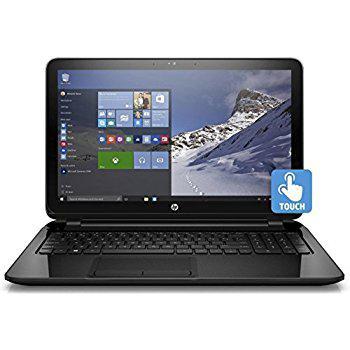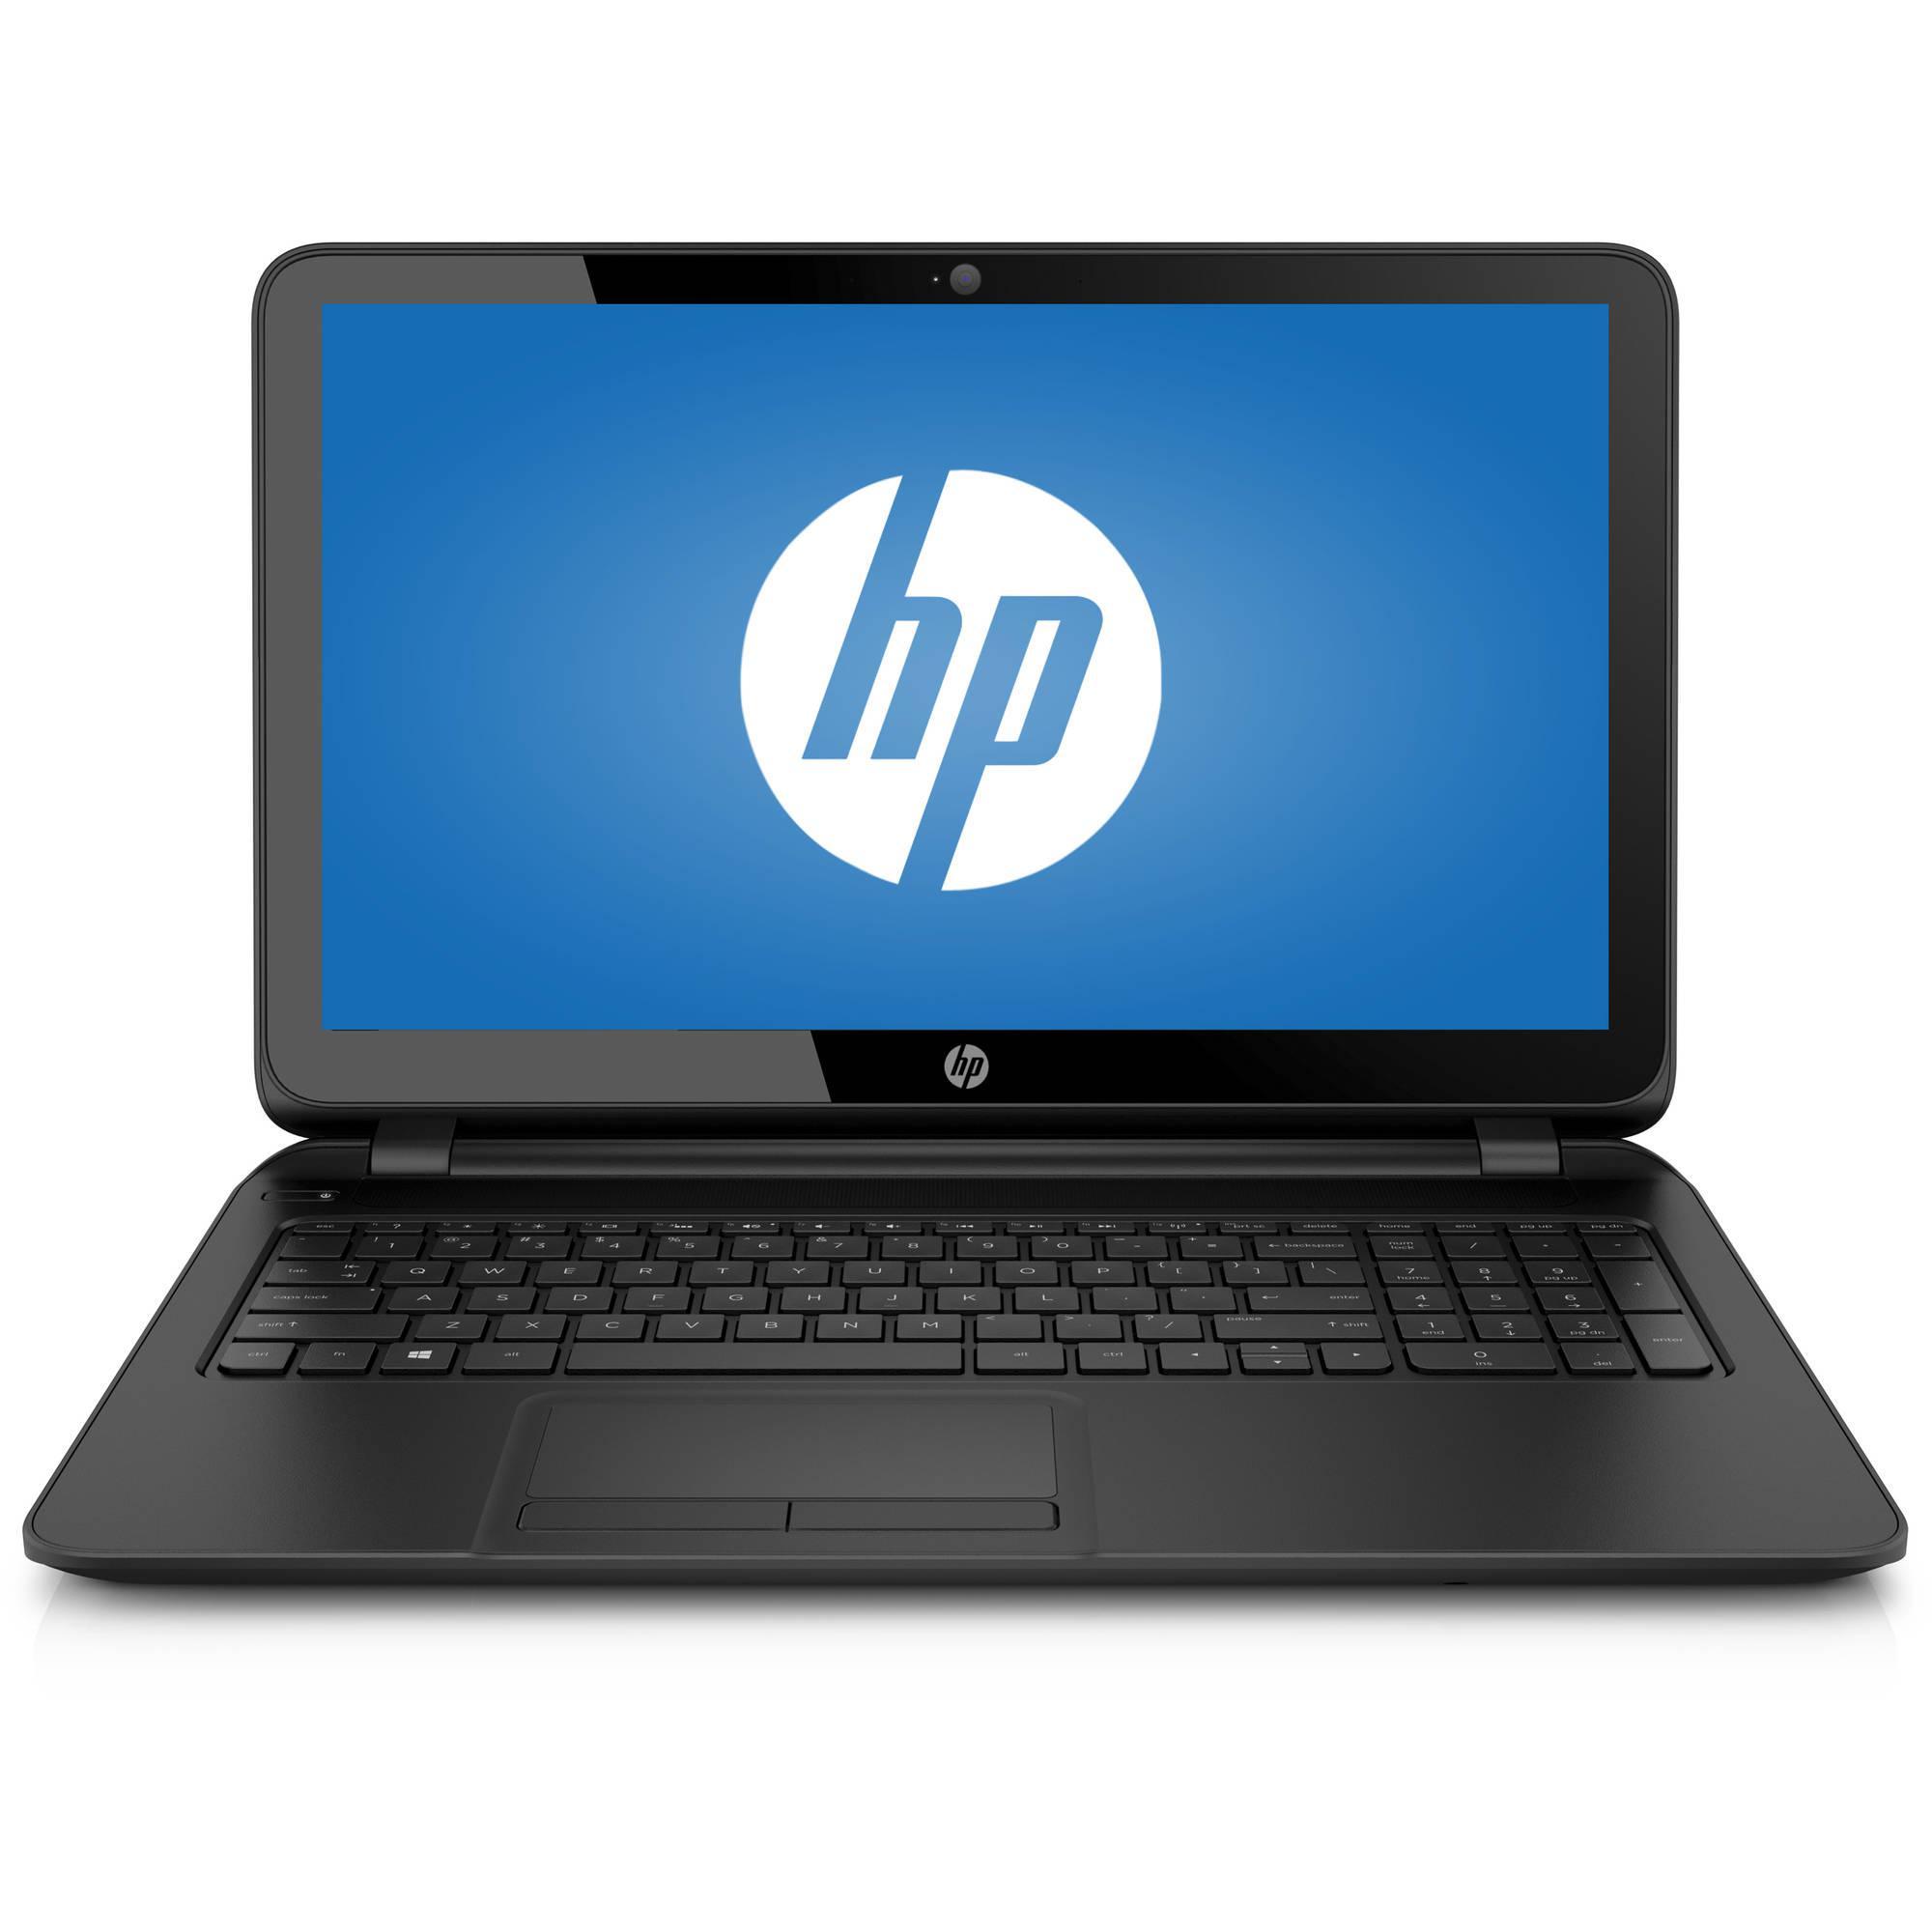The first image is the image on the left, the second image is the image on the right. Examine the images to the left and right. Is the description "The laptop on the right is displayed head-on, opened at a right angle, with its screen showing blue and white circle logo." accurate? Answer yes or no. Yes. The first image is the image on the left, the second image is the image on the right. For the images displayed, is the sentence "One laptop screen shows the HP logo and the other shows a windows desktop with a picture of a snowy mountain." factually correct? Answer yes or no. Yes. 